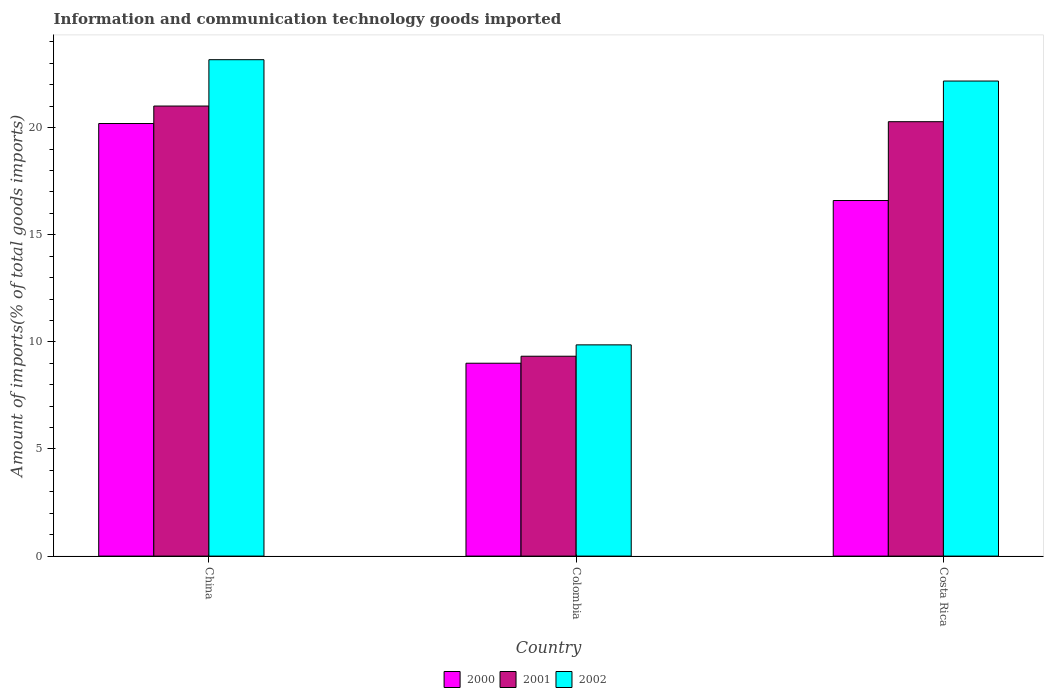How many groups of bars are there?
Your answer should be very brief. 3. Are the number of bars on each tick of the X-axis equal?
Make the answer very short. Yes. What is the amount of goods imported in 2002 in Costa Rica?
Give a very brief answer. 22.18. Across all countries, what is the maximum amount of goods imported in 2001?
Your answer should be very brief. 21.01. Across all countries, what is the minimum amount of goods imported in 2002?
Ensure brevity in your answer.  9.86. In which country was the amount of goods imported in 2000 maximum?
Give a very brief answer. China. In which country was the amount of goods imported in 2001 minimum?
Make the answer very short. Colombia. What is the total amount of goods imported in 2000 in the graph?
Offer a very short reply. 45.8. What is the difference between the amount of goods imported in 2002 in Colombia and that in Costa Rica?
Provide a succinct answer. -12.32. What is the difference between the amount of goods imported in 2002 in China and the amount of goods imported in 2001 in Colombia?
Provide a short and direct response. 13.84. What is the average amount of goods imported in 2000 per country?
Give a very brief answer. 15.27. What is the difference between the amount of goods imported of/in 2000 and amount of goods imported of/in 2002 in China?
Offer a very short reply. -2.98. What is the ratio of the amount of goods imported in 2000 in China to that in Costa Rica?
Provide a short and direct response. 1.22. Is the amount of goods imported in 2000 in Colombia less than that in Costa Rica?
Give a very brief answer. Yes. What is the difference between the highest and the second highest amount of goods imported in 2002?
Your response must be concise. -12.32. What is the difference between the highest and the lowest amount of goods imported in 2002?
Keep it short and to the point. 13.31. Is the sum of the amount of goods imported in 2000 in China and Costa Rica greater than the maximum amount of goods imported in 2002 across all countries?
Give a very brief answer. Yes. What does the 3rd bar from the left in China represents?
Offer a terse response. 2002. What does the 2nd bar from the right in China represents?
Keep it short and to the point. 2001. How many countries are there in the graph?
Provide a short and direct response. 3. What is the difference between two consecutive major ticks on the Y-axis?
Your response must be concise. 5. Does the graph contain any zero values?
Provide a succinct answer. No. How many legend labels are there?
Make the answer very short. 3. What is the title of the graph?
Provide a succinct answer. Information and communication technology goods imported. What is the label or title of the Y-axis?
Provide a succinct answer. Amount of imports(% of total goods imports). What is the Amount of imports(% of total goods imports) of 2000 in China?
Make the answer very short. 20.19. What is the Amount of imports(% of total goods imports) of 2001 in China?
Keep it short and to the point. 21.01. What is the Amount of imports(% of total goods imports) of 2002 in China?
Ensure brevity in your answer.  23.17. What is the Amount of imports(% of total goods imports) in 2000 in Colombia?
Provide a succinct answer. 9. What is the Amount of imports(% of total goods imports) of 2001 in Colombia?
Your answer should be compact. 9.33. What is the Amount of imports(% of total goods imports) in 2002 in Colombia?
Keep it short and to the point. 9.86. What is the Amount of imports(% of total goods imports) of 2000 in Costa Rica?
Your answer should be very brief. 16.6. What is the Amount of imports(% of total goods imports) in 2001 in Costa Rica?
Keep it short and to the point. 20.28. What is the Amount of imports(% of total goods imports) in 2002 in Costa Rica?
Give a very brief answer. 22.18. Across all countries, what is the maximum Amount of imports(% of total goods imports) of 2000?
Offer a terse response. 20.19. Across all countries, what is the maximum Amount of imports(% of total goods imports) in 2001?
Provide a succinct answer. 21.01. Across all countries, what is the maximum Amount of imports(% of total goods imports) of 2002?
Offer a very short reply. 23.17. Across all countries, what is the minimum Amount of imports(% of total goods imports) in 2000?
Give a very brief answer. 9. Across all countries, what is the minimum Amount of imports(% of total goods imports) of 2001?
Keep it short and to the point. 9.33. Across all countries, what is the minimum Amount of imports(% of total goods imports) in 2002?
Offer a terse response. 9.86. What is the total Amount of imports(% of total goods imports) of 2000 in the graph?
Make the answer very short. 45.8. What is the total Amount of imports(% of total goods imports) in 2001 in the graph?
Make the answer very short. 50.62. What is the total Amount of imports(% of total goods imports) of 2002 in the graph?
Offer a very short reply. 55.21. What is the difference between the Amount of imports(% of total goods imports) of 2000 in China and that in Colombia?
Keep it short and to the point. 11.19. What is the difference between the Amount of imports(% of total goods imports) of 2001 in China and that in Colombia?
Your answer should be very brief. 11.68. What is the difference between the Amount of imports(% of total goods imports) in 2002 in China and that in Colombia?
Your response must be concise. 13.31. What is the difference between the Amount of imports(% of total goods imports) in 2000 in China and that in Costa Rica?
Provide a succinct answer. 3.59. What is the difference between the Amount of imports(% of total goods imports) of 2001 in China and that in Costa Rica?
Provide a succinct answer. 0.73. What is the difference between the Amount of imports(% of total goods imports) in 2000 in Colombia and that in Costa Rica?
Give a very brief answer. -7.59. What is the difference between the Amount of imports(% of total goods imports) of 2001 in Colombia and that in Costa Rica?
Your answer should be very brief. -10.95. What is the difference between the Amount of imports(% of total goods imports) in 2002 in Colombia and that in Costa Rica?
Give a very brief answer. -12.32. What is the difference between the Amount of imports(% of total goods imports) of 2000 in China and the Amount of imports(% of total goods imports) of 2001 in Colombia?
Offer a very short reply. 10.86. What is the difference between the Amount of imports(% of total goods imports) of 2000 in China and the Amount of imports(% of total goods imports) of 2002 in Colombia?
Offer a terse response. 10.33. What is the difference between the Amount of imports(% of total goods imports) of 2001 in China and the Amount of imports(% of total goods imports) of 2002 in Colombia?
Provide a succinct answer. 11.15. What is the difference between the Amount of imports(% of total goods imports) of 2000 in China and the Amount of imports(% of total goods imports) of 2001 in Costa Rica?
Offer a terse response. -0.09. What is the difference between the Amount of imports(% of total goods imports) in 2000 in China and the Amount of imports(% of total goods imports) in 2002 in Costa Rica?
Ensure brevity in your answer.  -1.98. What is the difference between the Amount of imports(% of total goods imports) of 2001 in China and the Amount of imports(% of total goods imports) of 2002 in Costa Rica?
Provide a succinct answer. -1.17. What is the difference between the Amount of imports(% of total goods imports) in 2000 in Colombia and the Amount of imports(% of total goods imports) in 2001 in Costa Rica?
Give a very brief answer. -11.28. What is the difference between the Amount of imports(% of total goods imports) in 2000 in Colombia and the Amount of imports(% of total goods imports) in 2002 in Costa Rica?
Keep it short and to the point. -13.17. What is the difference between the Amount of imports(% of total goods imports) in 2001 in Colombia and the Amount of imports(% of total goods imports) in 2002 in Costa Rica?
Keep it short and to the point. -12.85. What is the average Amount of imports(% of total goods imports) in 2000 per country?
Your response must be concise. 15.27. What is the average Amount of imports(% of total goods imports) of 2001 per country?
Provide a short and direct response. 16.87. What is the average Amount of imports(% of total goods imports) in 2002 per country?
Your answer should be compact. 18.4. What is the difference between the Amount of imports(% of total goods imports) of 2000 and Amount of imports(% of total goods imports) of 2001 in China?
Give a very brief answer. -0.82. What is the difference between the Amount of imports(% of total goods imports) of 2000 and Amount of imports(% of total goods imports) of 2002 in China?
Keep it short and to the point. -2.98. What is the difference between the Amount of imports(% of total goods imports) in 2001 and Amount of imports(% of total goods imports) in 2002 in China?
Keep it short and to the point. -2.16. What is the difference between the Amount of imports(% of total goods imports) of 2000 and Amount of imports(% of total goods imports) of 2001 in Colombia?
Your answer should be compact. -0.33. What is the difference between the Amount of imports(% of total goods imports) of 2000 and Amount of imports(% of total goods imports) of 2002 in Colombia?
Your answer should be very brief. -0.86. What is the difference between the Amount of imports(% of total goods imports) of 2001 and Amount of imports(% of total goods imports) of 2002 in Colombia?
Provide a succinct answer. -0.53. What is the difference between the Amount of imports(% of total goods imports) in 2000 and Amount of imports(% of total goods imports) in 2001 in Costa Rica?
Offer a terse response. -3.68. What is the difference between the Amount of imports(% of total goods imports) of 2000 and Amount of imports(% of total goods imports) of 2002 in Costa Rica?
Provide a short and direct response. -5.58. What is the difference between the Amount of imports(% of total goods imports) of 2001 and Amount of imports(% of total goods imports) of 2002 in Costa Rica?
Give a very brief answer. -1.9. What is the ratio of the Amount of imports(% of total goods imports) in 2000 in China to that in Colombia?
Give a very brief answer. 2.24. What is the ratio of the Amount of imports(% of total goods imports) in 2001 in China to that in Colombia?
Make the answer very short. 2.25. What is the ratio of the Amount of imports(% of total goods imports) in 2002 in China to that in Colombia?
Offer a very short reply. 2.35. What is the ratio of the Amount of imports(% of total goods imports) of 2000 in China to that in Costa Rica?
Make the answer very short. 1.22. What is the ratio of the Amount of imports(% of total goods imports) in 2001 in China to that in Costa Rica?
Provide a succinct answer. 1.04. What is the ratio of the Amount of imports(% of total goods imports) in 2002 in China to that in Costa Rica?
Your answer should be compact. 1.04. What is the ratio of the Amount of imports(% of total goods imports) in 2000 in Colombia to that in Costa Rica?
Provide a succinct answer. 0.54. What is the ratio of the Amount of imports(% of total goods imports) of 2001 in Colombia to that in Costa Rica?
Provide a short and direct response. 0.46. What is the ratio of the Amount of imports(% of total goods imports) of 2002 in Colombia to that in Costa Rica?
Keep it short and to the point. 0.44. What is the difference between the highest and the second highest Amount of imports(% of total goods imports) of 2000?
Offer a terse response. 3.59. What is the difference between the highest and the second highest Amount of imports(% of total goods imports) in 2001?
Make the answer very short. 0.73. What is the difference between the highest and the second highest Amount of imports(% of total goods imports) in 2002?
Ensure brevity in your answer.  1. What is the difference between the highest and the lowest Amount of imports(% of total goods imports) of 2000?
Give a very brief answer. 11.19. What is the difference between the highest and the lowest Amount of imports(% of total goods imports) of 2001?
Provide a short and direct response. 11.68. What is the difference between the highest and the lowest Amount of imports(% of total goods imports) of 2002?
Ensure brevity in your answer.  13.31. 